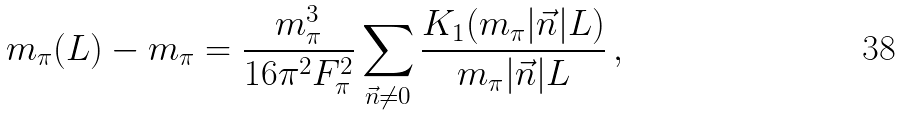Convert formula to latex. <formula><loc_0><loc_0><loc_500><loc_500>m _ { \pi } ( L ) - m _ { \pi } = \frac { m _ { \pi } ^ { 3 } } { 1 6 \pi ^ { 2 } F _ { \pi } ^ { 2 } } \sum _ { \vec { n } \neq 0 } \frac { K _ { 1 } ( m _ { \pi } | \vec { n } | L ) } { m _ { \pi } | \vec { n } | L } \, ,</formula> 